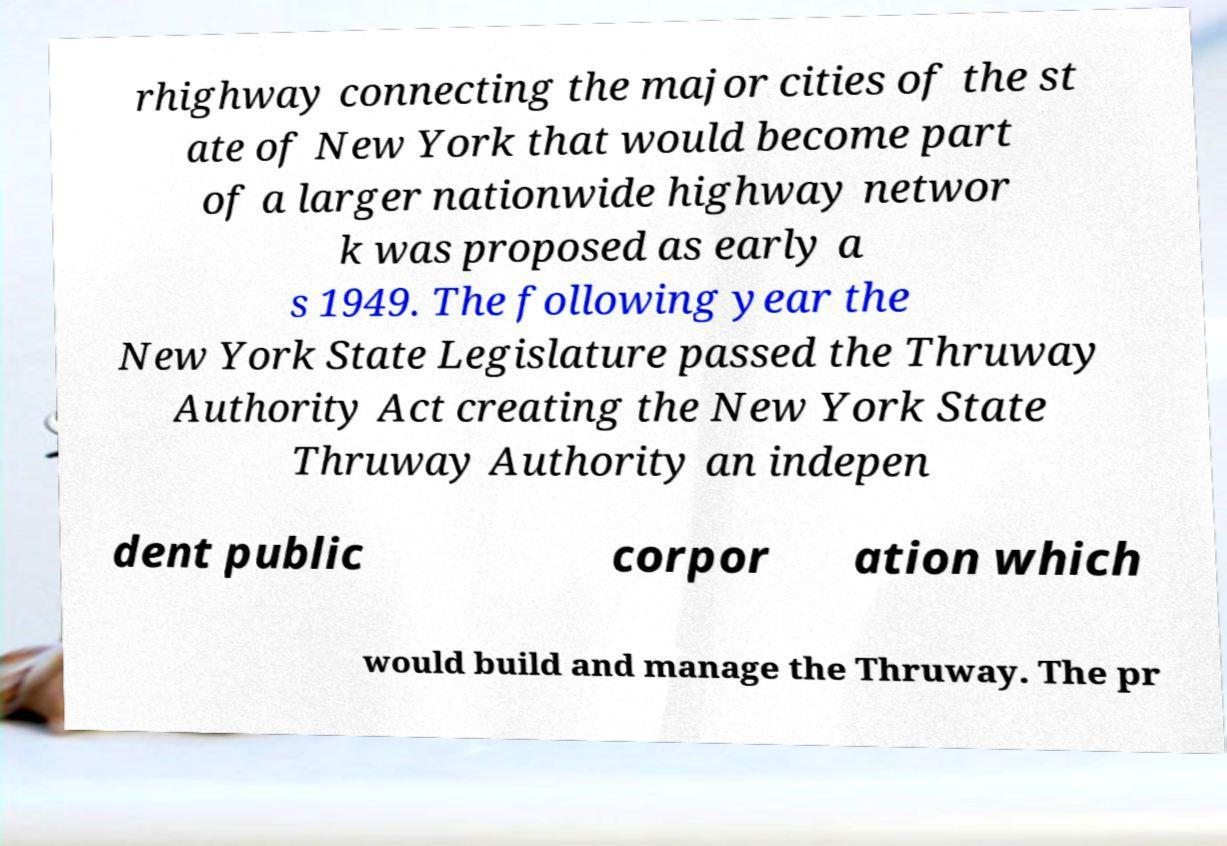What messages or text are displayed in this image? I need them in a readable, typed format. rhighway connecting the major cities of the st ate of New York that would become part of a larger nationwide highway networ k was proposed as early a s 1949. The following year the New York State Legislature passed the Thruway Authority Act creating the New York State Thruway Authority an indepen dent public corpor ation which would build and manage the Thruway. The pr 